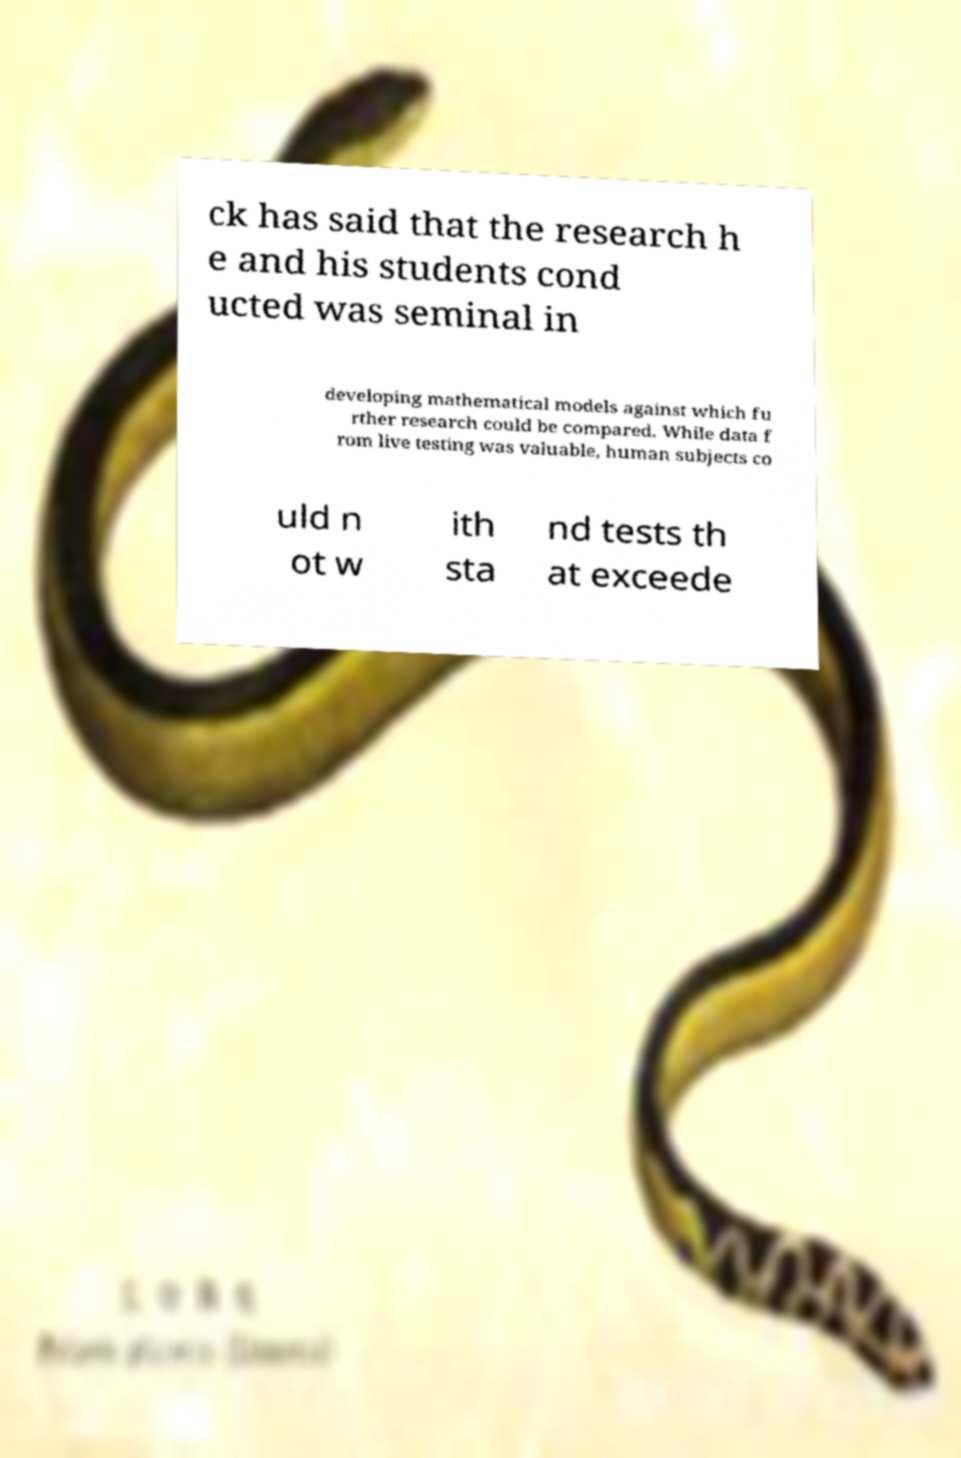There's text embedded in this image that I need extracted. Can you transcribe it verbatim? ck has said that the research h e and his students cond ucted was seminal in developing mathematical models against which fu rther research could be compared. While data f rom live testing was valuable, human subjects co uld n ot w ith sta nd tests th at exceede 